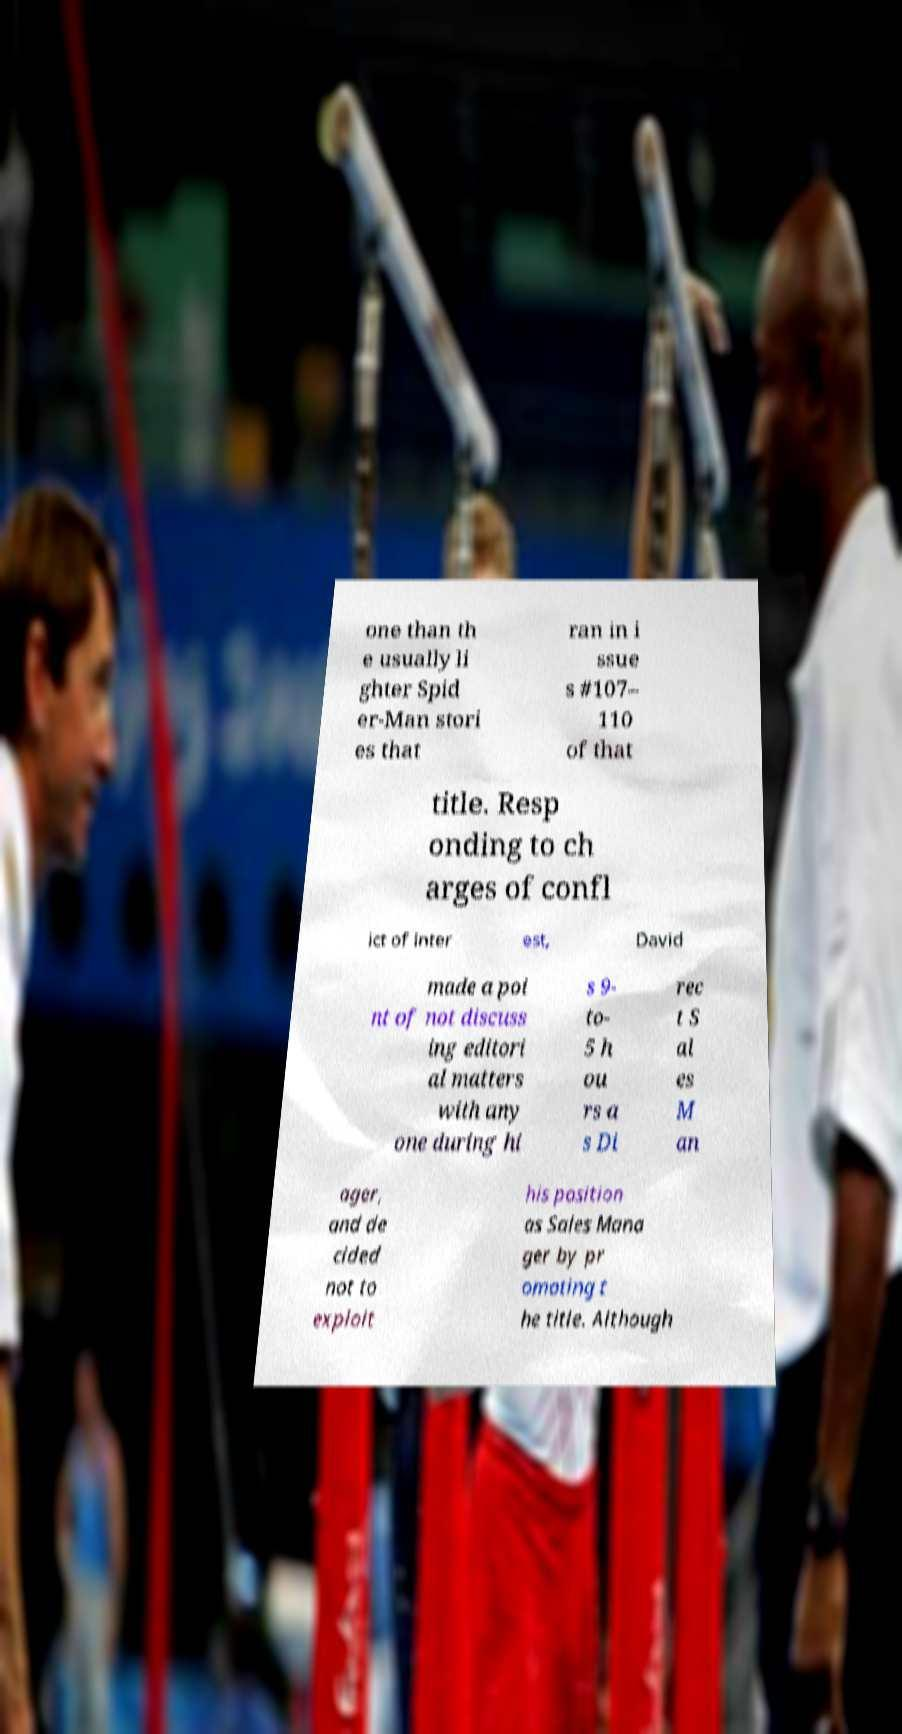Can you accurately transcribe the text from the provided image for me? one than th e usually li ghter Spid er-Man stori es that ran in i ssue s #107– 110 of that title. Resp onding to ch arges of confl ict of inter est, David made a poi nt of not discuss ing editori al matters with any one during hi s 9- to- 5 h ou rs a s Di rec t S al es M an ager, and de cided not to exploit his position as Sales Mana ger by pr omoting t he title. Although 